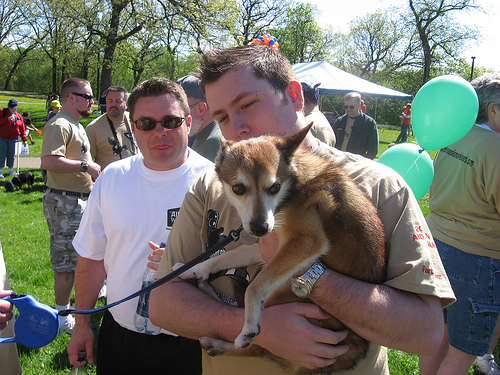<image>
Is there a dog behind the man? No. The dog is not behind the man. From this viewpoint, the dog appears to be positioned elsewhere in the scene. 